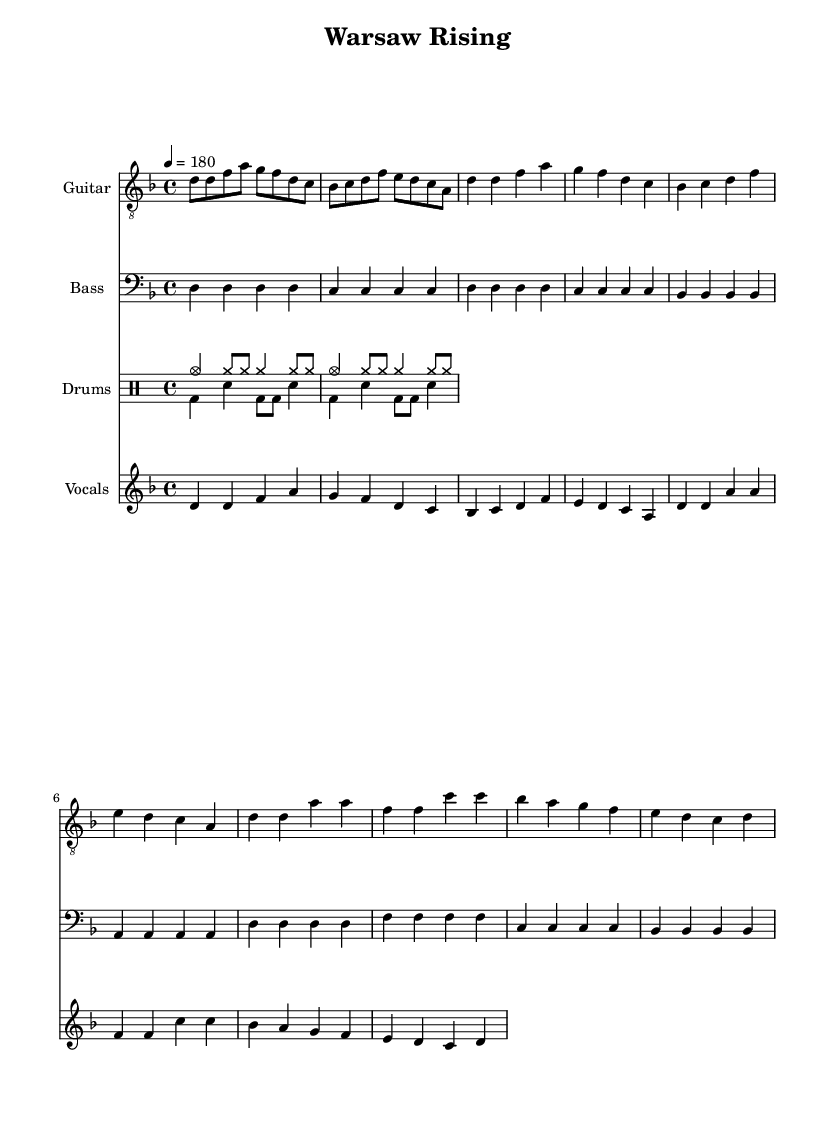What is the key signature of this music? The key signature is D minor, which features one flat (B flat). This can be determined by looking at the key signature indicated at the beginning of the staff.
Answer: D minor What is the time signature of this music? The time signature is 4/4, found at the beginning of the score. This indicates that there are four beats in each measure and the quarter note receives one beat.
Answer: 4/4 What is the tempo marking for this piece? The tempo marking is indicated as 180 beats per minute (BPM), which is shown next to the word "tempo" at the beginning of the music.
Answer: 180 What instrument plays the melody during the verse? The vocals play the melody during the verse, as indicated by the staff labelled "Vocals" which contains the melody notes and lyrics.
Answer: Vocals How many measures are there in the chorus section? There are four measures in the chorus section, which can be counted by examining the music notation provided specifically for the chorus part.
Answer: Four What type of beat is primarily used in the drum part? A basic punk beat is primarily used in the drum part, as indicated by the drum patterns labelled as "drumsUp", which reflects typical punk drumming style with a strong emphasis on cymbals and bass drums.
Answer: Basic punk beat What lyrical theme is depicted in the song? The lyrical theme is centered around the resistance against the Nazi regime, as reflected in the lyrics provided. The words "Warsaw rising" and "against the Nazi machine" clearly point to this theme.
Answer: Polish Resistance 